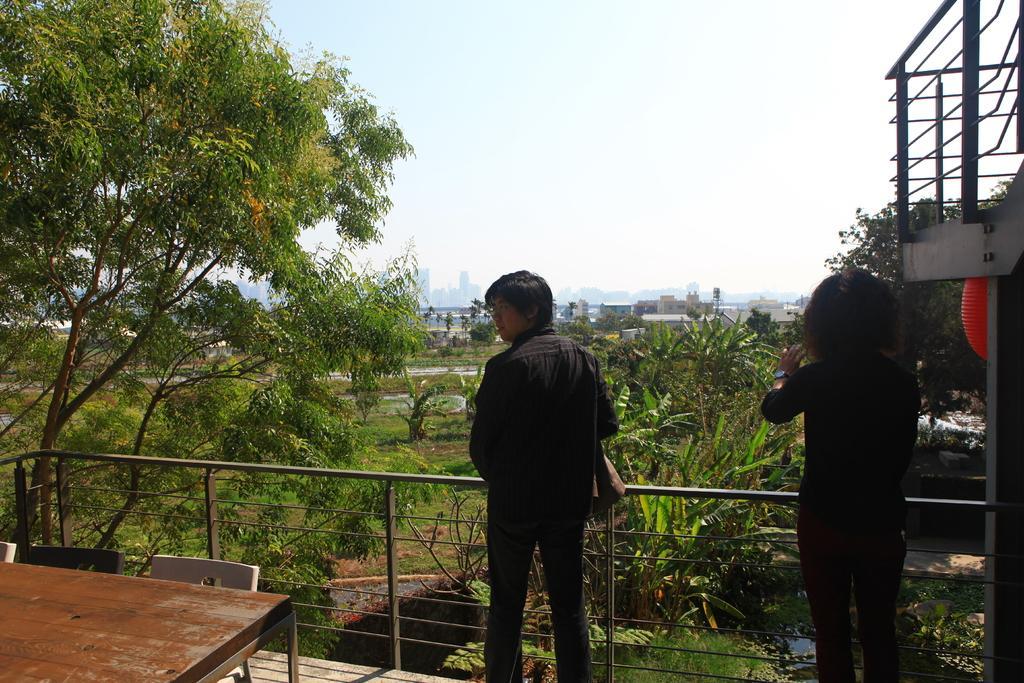In one or two sentences, can you explain what this image depicts? In this picture we can see a table, chairs and couple of people are in front of metal fence, and we can find couple of trees and buildings. 